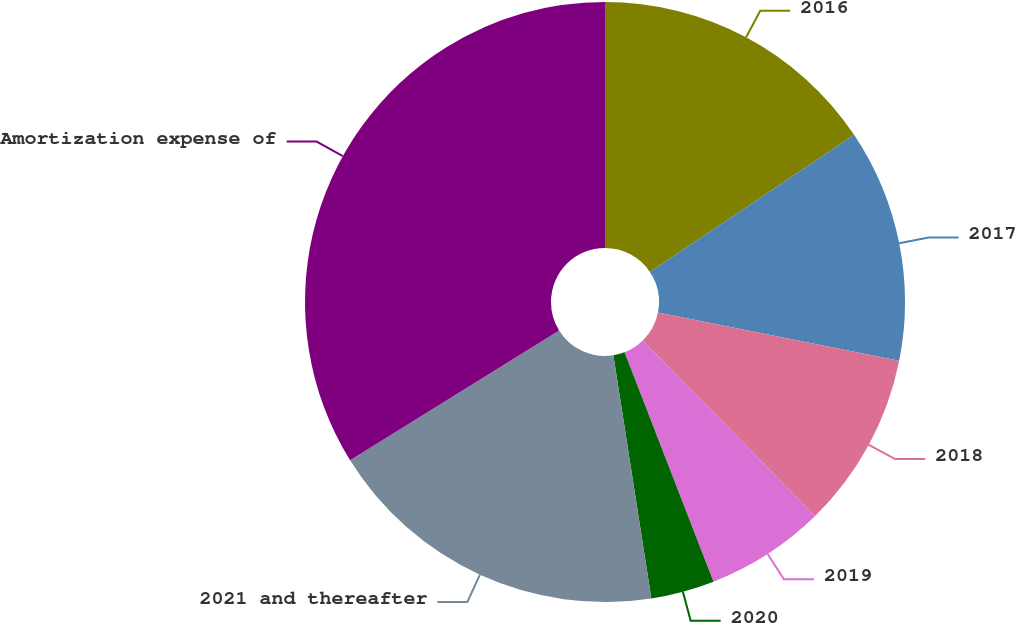Convert chart. <chart><loc_0><loc_0><loc_500><loc_500><pie_chart><fcel>2016<fcel>2017<fcel>2018<fcel>2019<fcel>2020<fcel>2021 and thereafter<fcel>Amortization expense of<nl><fcel>15.59%<fcel>12.55%<fcel>9.51%<fcel>6.46%<fcel>3.42%<fcel>18.63%<fcel>33.84%<nl></chart> 